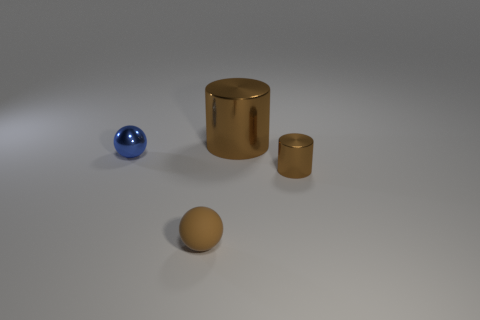Subtract all blue spheres. How many spheres are left? 1 Add 1 large blue matte cylinders. How many objects exist? 5 Subtract 0 cyan spheres. How many objects are left? 4 Subtract all gray balls. Subtract all green cylinders. How many balls are left? 2 Subtract all purple cylinders. How many blue balls are left? 1 Subtract all small red things. Subtract all small matte balls. How many objects are left? 3 Add 3 large cylinders. How many large cylinders are left? 4 Add 3 metal blocks. How many metal blocks exist? 3 